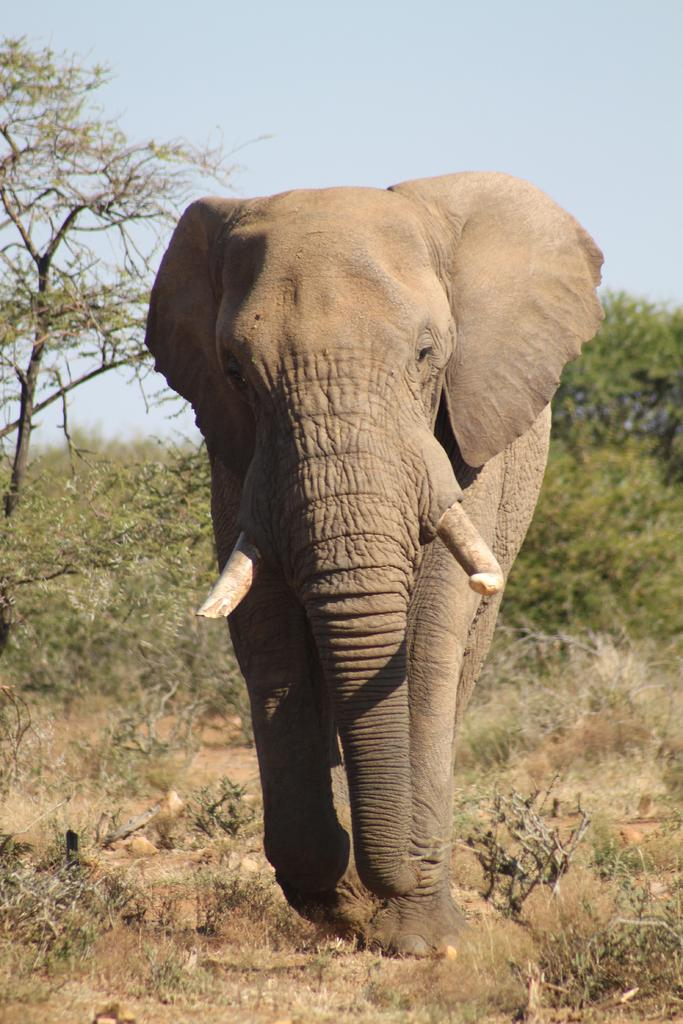What animal is present in the image? There is an elephant in the image. What color is the elephant? The elephant is brown. What can be seen in the background of the image? There are trees and the sky visible in the background of the image. What color are the trees? The trees are green. What color is the sky in the image? The sky is white in the image. Can you see the elephant playing with a ball in the image? There is no ball or indication of play in the image; it only features an elephant, trees, and the sky. How many eyes does the elephant have in the image? The image does not show the number of eyes the elephant has, but since it is an elephant, it typically has two eyes. 